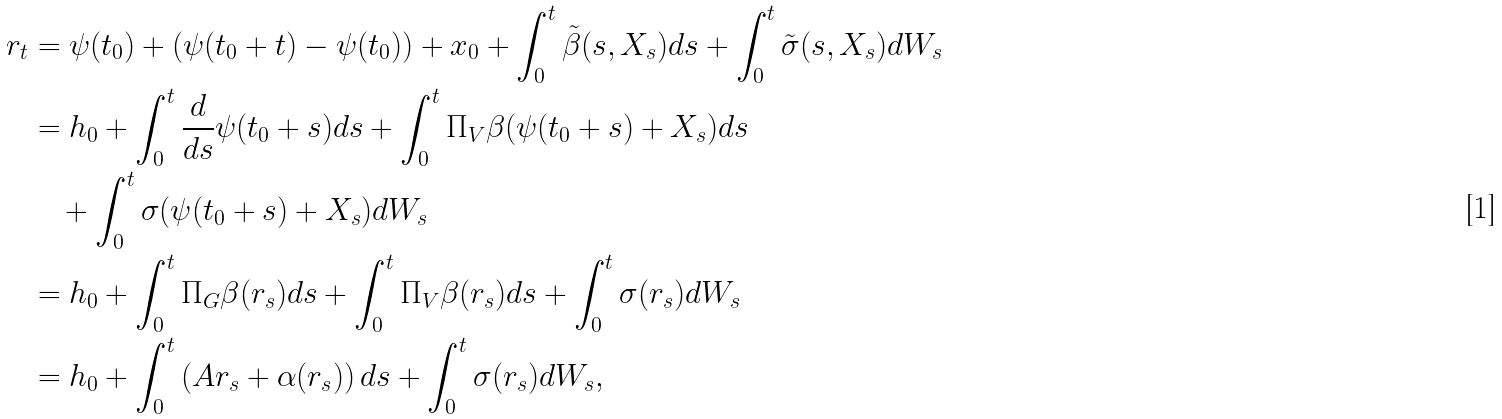Convert formula to latex. <formula><loc_0><loc_0><loc_500><loc_500>r _ { t } & = \psi ( t _ { 0 } ) + \left ( \psi ( t _ { 0 } + t ) - \psi ( t _ { 0 } ) \right ) + x _ { 0 } + \int _ { 0 } ^ { t } \tilde { \beta } ( s , X _ { s } ) d s + \int _ { 0 } ^ { t } \tilde { \sigma } ( s , X _ { s } ) d W _ { s } \\ & = h _ { 0 } + \int _ { 0 } ^ { t } \frac { d } { d s } \psi ( t _ { 0 } + s ) d s + \int _ { 0 } ^ { t } \Pi _ { V } \beta ( \psi ( t _ { 0 } + s ) + X _ { s } ) d s \\ & \quad + \int _ { 0 } ^ { t } \sigma ( \psi ( t _ { 0 } + s ) + X _ { s } ) d W _ { s } \\ & = h _ { 0 } + \int _ { 0 } ^ { t } \Pi _ { G } \beta ( r _ { s } ) d s + \int _ { 0 } ^ { t } \Pi _ { V } \beta ( r _ { s } ) d s + \int _ { 0 } ^ { t } \sigma ( r _ { s } ) d W _ { s } \\ & = h _ { 0 } + \int _ { 0 } ^ { t } \left ( A r _ { s } + \alpha ( r _ { s } ) \right ) d s + \int _ { 0 } ^ { t } \sigma ( r _ { s } ) d W _ { s } ,</formula> 